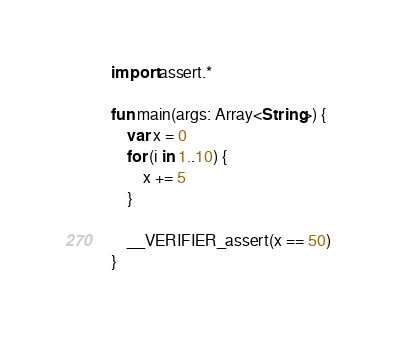<code> <loc_0><loc_0><loc_500><loc_500><_Kotlin_>import assert.*

fun main(args: Array<String>) {
    var x = 0
    for (i in 1..10) {
        x += 5
    }

    __VERIFIER_assert(x == 50)
}
</code> 